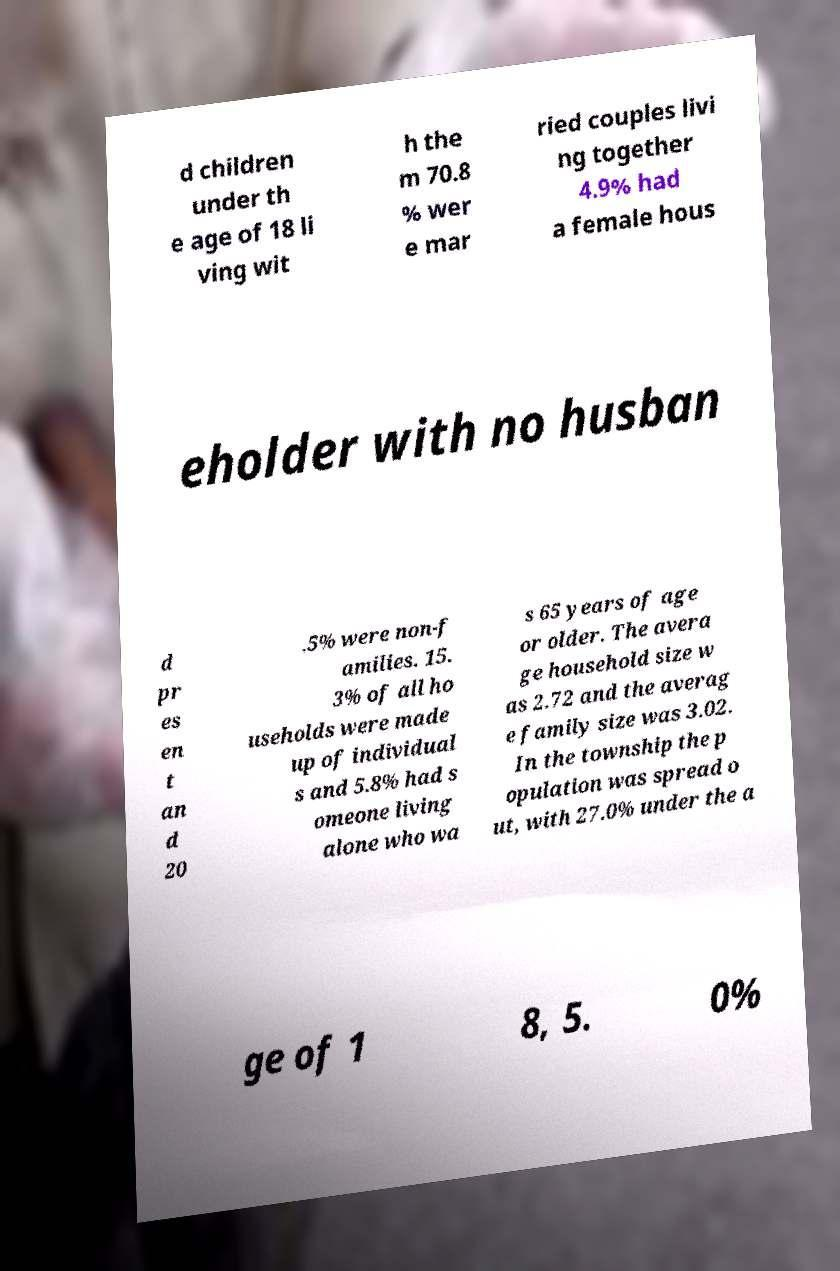Could you extract and type out the text from this image? d children under th e age of 18 li ving wit h the m 70.8 % wer e mar ried couples livi ng together 4.9% had a female hous eholder with no husban d pr es en t an d 20 .5% were non-f amilies. 15. 3% of all ho useholds were made up of individual s and 5.8% had s omeone living alone who wa s 65 years of age or older. The avera ge household size w as 2.72 and the averag e family size was 3.02. In the township the p opulation was spread o ut, with 27.0% under the a ge of 1 8, 5. 0% 